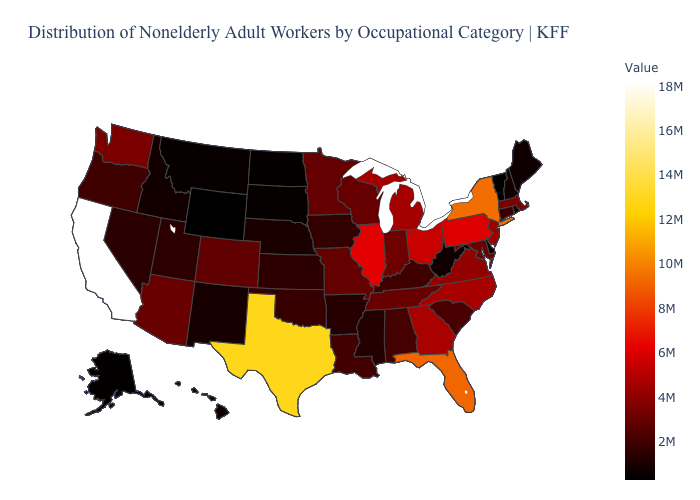Among the states that border Florida , which have the lowest value?
Be succinct. Alabama. Which states have the highest value in the USA?
Be succinct. California. Which states have the highest value in the USA?
Answer briefly. California. Does Oklahoma have the highest value in the USA?
Concise answer only. No. 